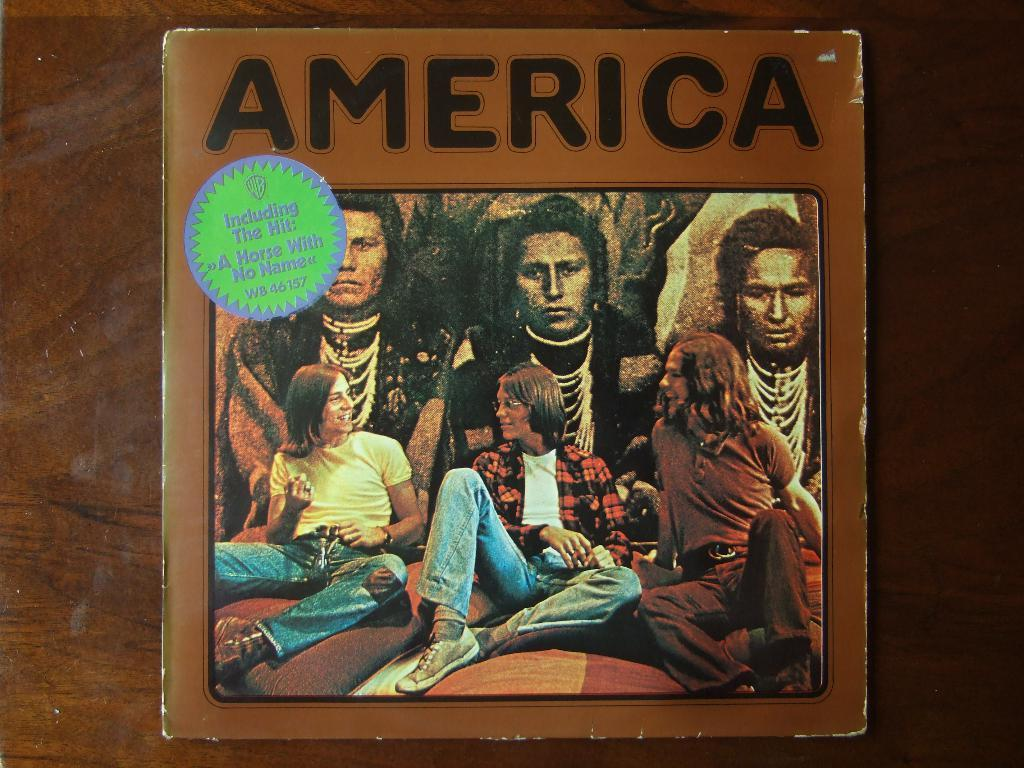<image>
Relay a brief, clear account of the picture shown. A record album by the band America sits on a table 